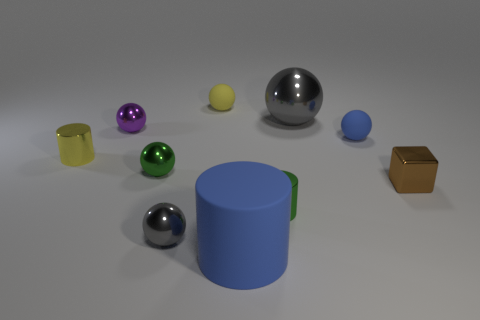Subtract all green balls. How many balls are left? 5 Subtract all green cylinders. How many cylinders are left? 2 Subtract all cylinders. How many objects are left? 7 Subtract 3 spheres. How many spheres are left? 3 Subtract all blue spheres. Subtract all yellow cylinders. How many spheres are left? 5 Subtract all red spheres. How many green blocks are left? 0 Subtract all tiny purple things. Subtract all tiny green things. How many objects are left? 7 Add 3 green things. How many green things are left? 5 Add 8 blue matte cylinders. How many blue matte cylinders exist? 9 Subtract 0 cyan cylinders. How many objects are left? 10 